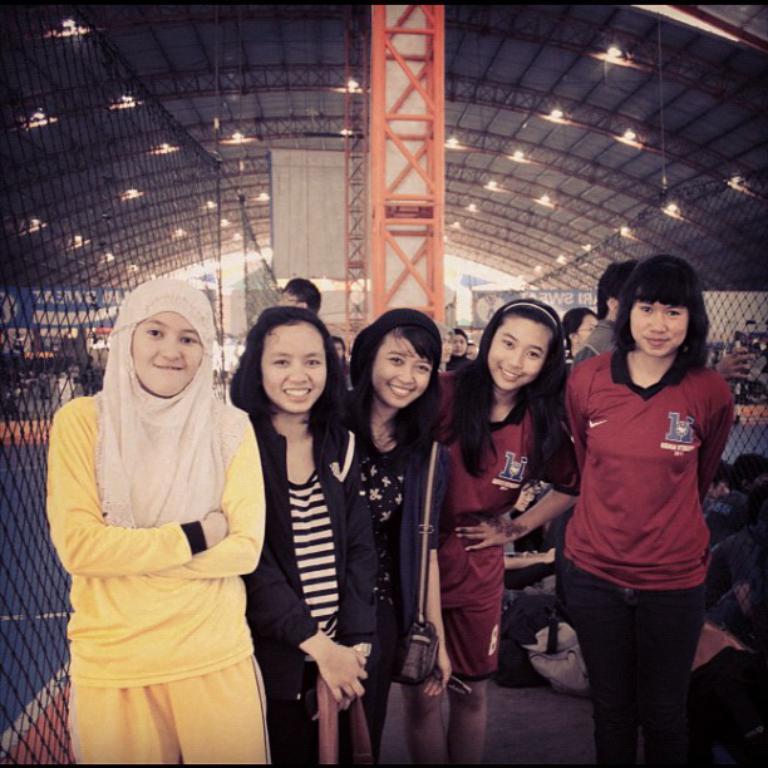Describe this image in one or two sentences. In the image a group of women were posing for the photo, on the left side there is a mesh and there is a big roof above them. 